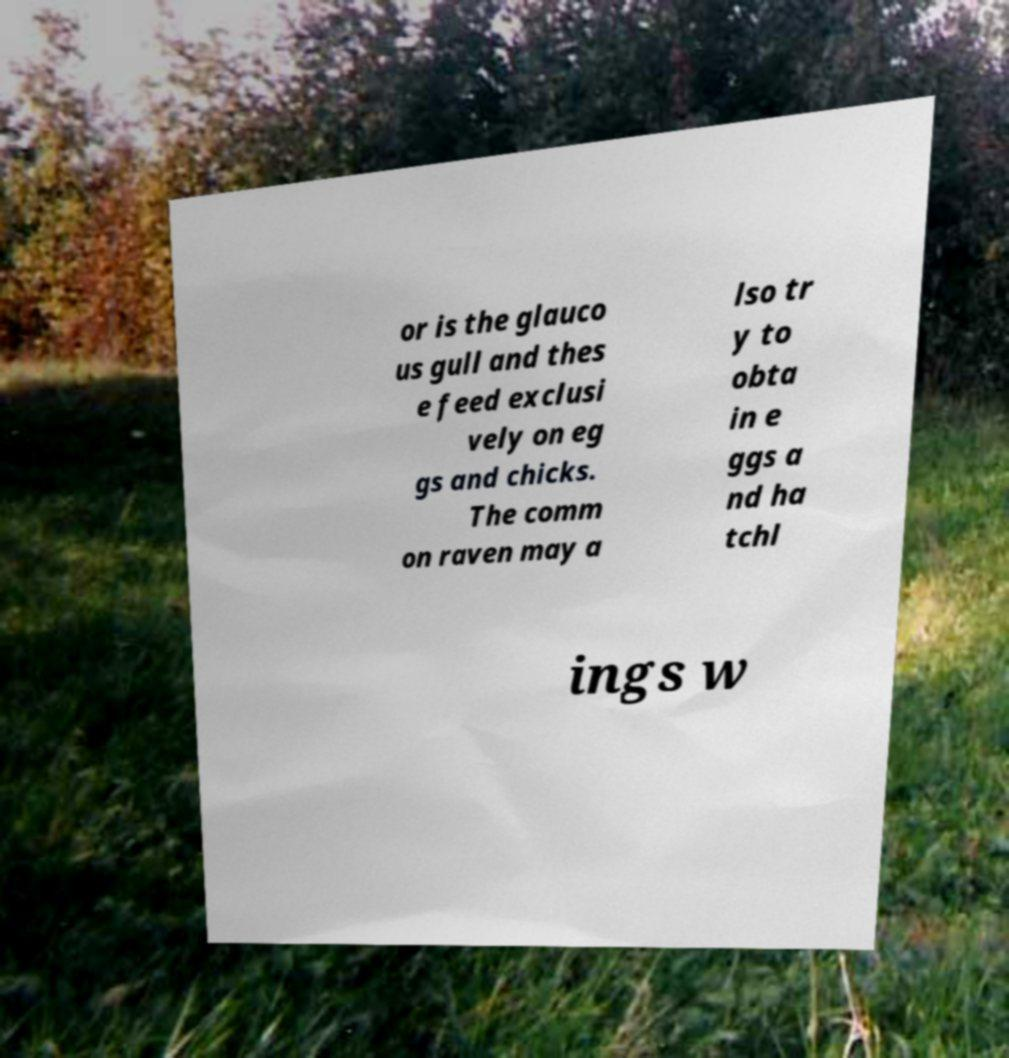Can you accurately transcribe the text from the provided image for me? or is the glauco us gull and thes e feed exclusi vely on eg gs and chicks. The comm on raven may a lso tr y to obta in e ggs a nd ha tchl ings w 